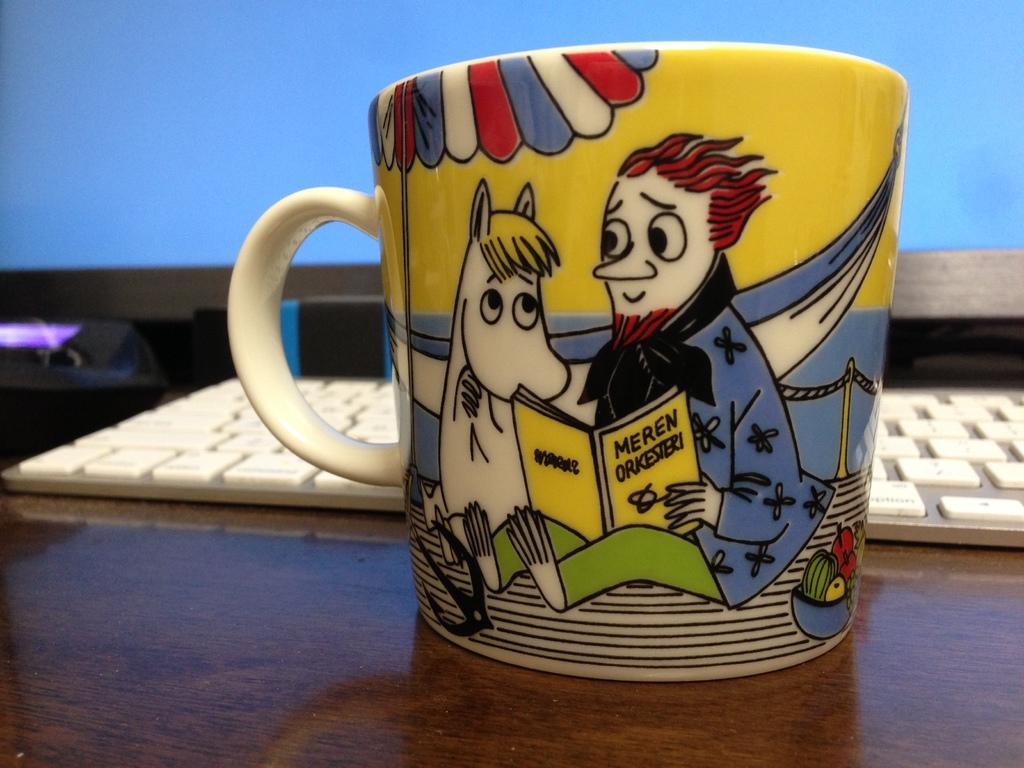<image>
Relay a brief, clear account of the picture shown. Cup showing a man reading a book titled "Meren Orkeisieri" to a horse. 